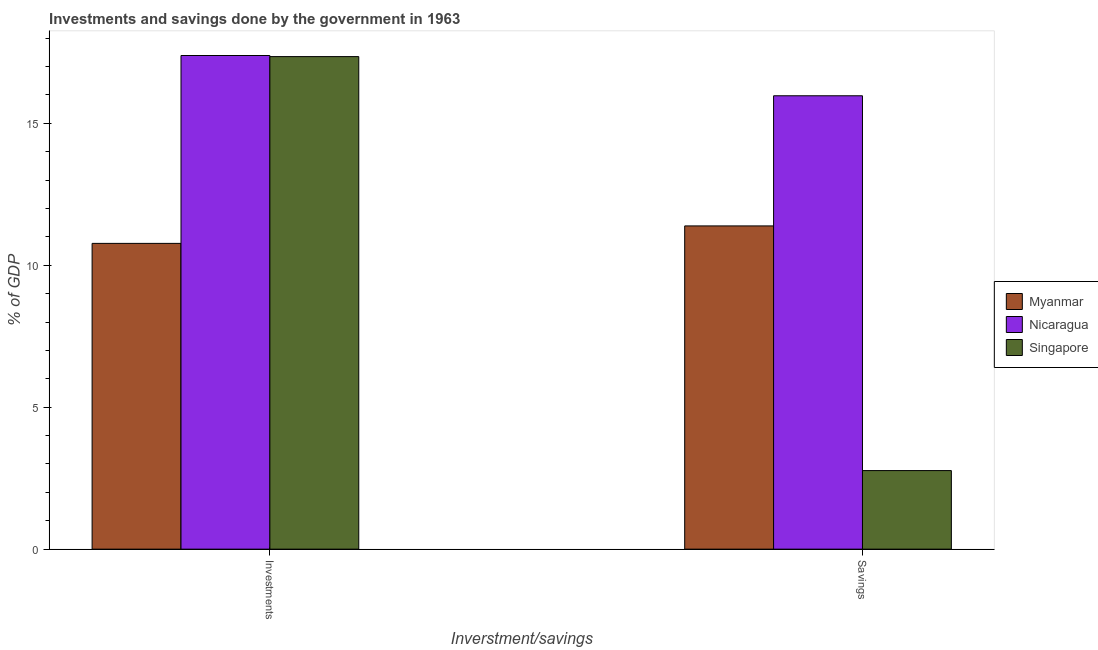How many different coloured bars are there?
Offer a terse response. 3. How many groups of bars are there?
Ensure brevity in your answer.  2. Are the number of bars on each tick of the X-axis equal?
Give a very brief answer. Yes. How many bars are there on the 1st tick from the left?
Give a very brief answer. 3. What is the label of the 1st group of bars from the left?
Keep it short and to the point. Investments. What is the savings of government in Singapore?
Give a very brief answer. 2.77. Across all countries, what is the maximum investments of government?
Provide a short and direct response. 17.39. Across all countries, what is the minimum investments of government?
Your response must be concise. 10.77. In which country was the investments of government maximum?
Keep it short and to the point. Nicaragua. In which country was the investments of government minimum?
Your response must be concise. Myanmar. What is the total savings of government in the graph?
Offer a very short reply. 30.12. What is the difference between the savings of government in Nicaragua and that in Myanmar?
Your answer should be compact. 4.58. What is the difference between the savings of government in Nicaragua and the investments of government in Myanmar?
Provide a succinct answer. 5.2. What is the average investments of government per country?
Make the answer very short. 15.17. What is the difference between the investments of government and savings of government in Singapore?
Provide a succinct answer. 14.58. In how many countries, is the savings of government greater than 10 %?
Offer a very short reply. 2. What is the ratio of the savings of government in Singapore to that in Nicaragua?
Your answer should be very brief. 0.17. Is the savings of government in Singapore less than that in Myanmar?
Keep it short and to the point. Yes. What does the 3rd bar from the left in Investments represents?
Keep it short and to the point. Singapore. What does the 2nd bar from the right in Savings represents?
Provide a short and direct response. Nicaragua. Are all the bars in the graph horizontal?
Provide a succinct answer. No. How many countries are there in the graph?
Provide a succinct answer. 3. What is the difference between two consecutive major ticks on the Y-axis?
Provide a succinct answer. 5. Does the graph contain any zero values?
Ensure brevity in your answer.  No. How many legend labels are there?
Offer a very short reply. 3. How are the legend labels stacked?
Ensure brevity in your answer.  Vertical. What is the title of the graph?
Provide a succinct answer. Investments and savings done by the government in 1963. Does "Nepal" appear as one of the legend labels in the graph?
Offer a very short reply. No. What is the label or title of the X-axis?
Keep it short and to the point. Inverstment/savings. What is the label or title of the Y-axis?
Ensure brevity in your answer.  % of GDP. What is the % of GDP in Myanmar in Investments?
Your answer should be very brief. 10.77. What is the % of GDP in Nicaragua in Investments?
Your answer should be very brief. 17.39. What is the % of GDP of Singapore in Investments?
Offer a very short reply. 17.35. What is the % of GDP in Myanmar in Savings?
Ensure brevity in your answer.  11.38. What is the % of GDP in Nicaragua in Savings?
Give a very brief answer. 15.97. What is the % of GDP in Singapore in Savings?
Make the answer very short. 2.77. Across all Inverstment/savings, what is the maximum % of GDP of Myanmar?
Provide a succinct answer. 11.38. Across all Inverstment/savings, what is the maximum % of GDP in Nicaragua?
Offer a terse response. 17.39. Across all Inverstment/savings, what is the maximum % of GDP of Singapore?
Make the answer very short. 17.35. Across all Inverstment/savings, what is the minimum % of GDP of Myanmar?
Offer a very short reply. 10.77. Across all Inverstment/savings, what is the minimum % of GDP in Nicaragua?
Provide a succinct answer. 15.97. Across all Inverstment/savings, what is the minimum % of GDP of Singapore?
Provide a short and direct response. 2.77. What is the total % of GDP in Myanmar in the graph?
Your answer should be compact. 22.15. What is the total % of GDP in Nicaragua in the graph?
Your answer should be compact. 33.35. What is the total % of GDP in Singapore in the graph?
Your answer should be compact. 20.12. What is the difference between the % of GDP of Myanmar in Investments and that in Savings?
Your answer should be compact. -0.62. What is the difference between the % of GDP in Nicaragua in Investments and that in Savings?
Give a very brief answer. 1.42. What is the difference between the % of GDP of Singapore in Investments and that in Savings?
Keep it short and to the point. 14.58. What is the difference between the % of GDP of Myanmar in Investments and the % of GDP of Nicaragua in Savings?
Provide a succinct answer. -5.2. What is the difference between the % of GDP in Myanmar in Investments and the % of GDP in Singapore in Savings?
Offer a terse response. 8. What is the difference between the % of GDP of Nicaragua in Investments and the % of GDP of Singapore in Savings?
Your answer should be compact. 14.62. What is the average % of GDP of Myanmar per Inverstment/savings?
Keep it short and to the point. 11.08. What is the average % of GDP in Nicaragua per Inverstment/savings?
Keep it short and to the point. 16.68. What is the average % of GDP in Singapore per Inverstment/savings?
Your answer should be very brief. 10.06. What is the difference between the % of GDP in Myanmar and % of GDP in Nicaragua in Investments?
Your response must be concise. -6.62. What is the difference between the % of GDP of Myanmar and % of GDP of Singapore in Investments?
Your response must be concise. -6.58. What is the difference between the % of GDP of Nicaragua and % of GDP of Singapore in Investments?
Keep it short and to the point. 0.04. What is the difference between the % of GDP of Myanmar and % of GDP of Nicaragua in Savings?
Provide a short and direct response. -4.58. What is the difference between the % of GDP of Myanmar and % of GDP of Singapore in Savings?
Your response must be concise. 8.62. What is the difference between the % of GDP of Nicaragua and % of GDP of Singapore in Savings?
Offer a terse response. 13.2. What is the ratio of the % of GDP in Myanmar in Investments to that in Savings?
Keep it short and to the point. 0.95. What is the ratio of the % of GDP of Nicaragua in Investments to that in Savings?
Make the answer very short. 1.09. What is the ratio of the % of GDP of Singapore in Investments to that in Savings?
Ensure brevity in your answer.  6.27. What is the difference between the highest and the second highest % of GDP in Myanmar?
Offer a very short reply. 0.62. What is the difference between the highest and the second highest % of GDP of Nicaragua?
Give a very brief answer. 1.42. What is the difference between the highest and the second highest % of GDP in Singapore?
Your answer should be very brief. 14.58. What is the difference between the highest and the lowest % of GDP of Myanmar?
Your answer should be very brief. 0.62. What is the difference between the highest and the lowest % of GDP in Nicaragua?
Your response must be concise. 1.42. What is the difference between the highest and the lowest % of GDP of Singapore?
Provide a succinct answer. 14.58. 